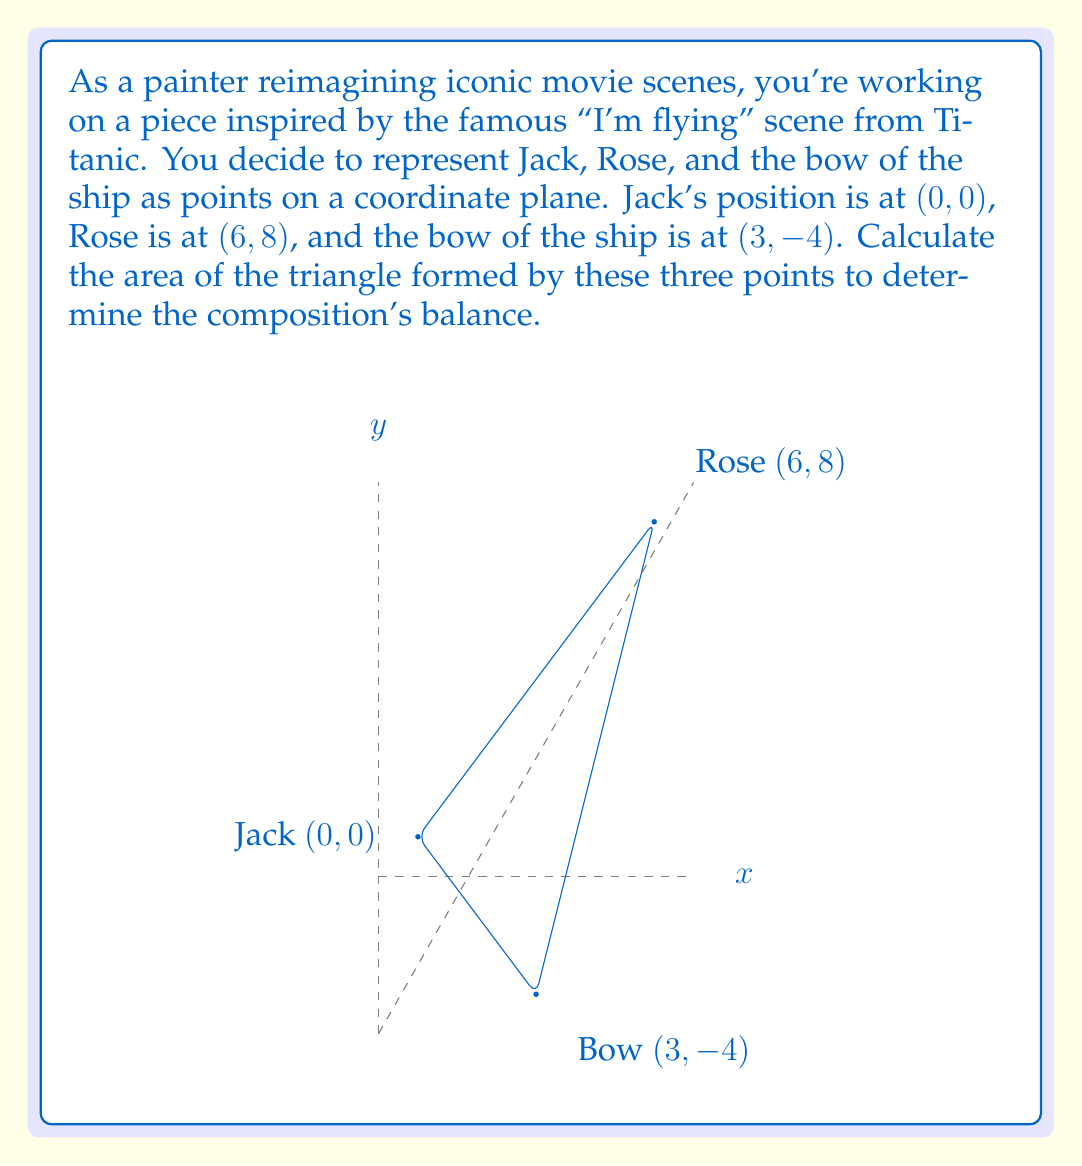Can you solve this math problem? To calculate the area of a triangle given three points on a coordinate plane, we can use the formula:

$$Area = \frac{1}{2}|x_1(y_2 - y_3) + x_2(y_3 - y_1) + x_3(y_1 - y_2)|$$

Where $(x_1, y_1)$, $(x_2, y_2)$, and $(x_3, y_3)$ are the coordinates of the three points.

Let's assign our points:
$(x_1, y_1) = (0, 0)$ (Jack)
$(x_2, y_2) = (6, 8)$ (Rose)
$(x_3, y_3) = (3, -4)$ (Bow)

Now, let's substitute these values into the formula:

$$\begin{align}
Area &= \frac{1}{2}|0(8 - (-4)) + 6((-4) - 0) + 3(0 - 8)| \\
&= \frac{1}{2}|0(12) + 6(-4) + 3(-8)| \\
&= \frac{1}{2}|0 - 24 - 24| \\
&= \frac{1}{2}|-48| \\
&= \frac{1}{2}(48) \\
&= 24
\end{align}$$

Therefore, the area of the triangle is 24 square units.
Answer: 24 square units 